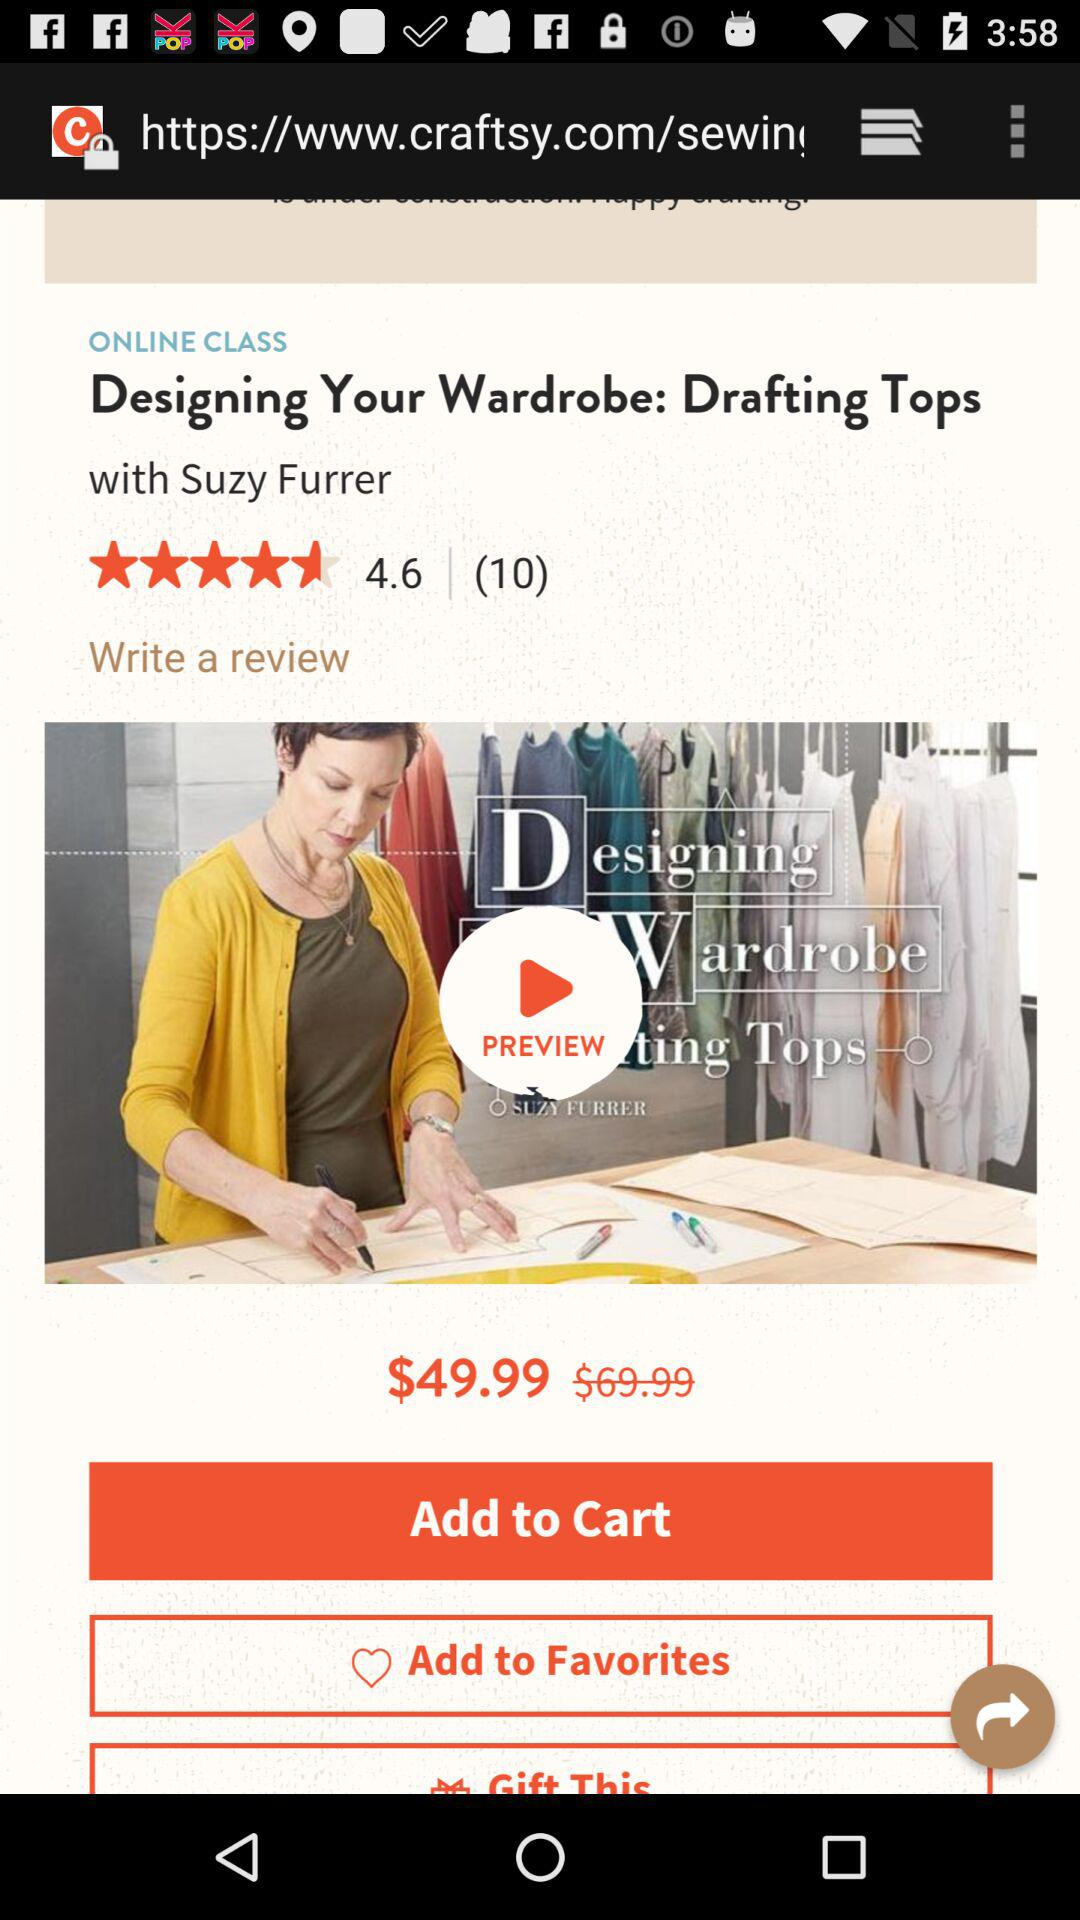How many reviews are there? There are 10 reviews. 